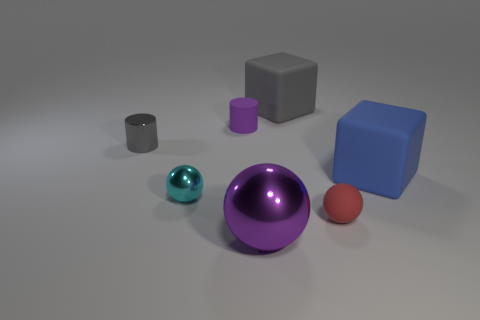There is a small thing that is the same color as the big sphere; what is it made of?
Provide a short and direct response. Rubber. Do the small red object and the small cyan ball have the same material?
Offer a very short reply. No. How many things are either green matte cubes or cylinders?
Provide a succinct answer. 2. What is the shape of the big thing behind the blue rubber cube?
Provide a short and direct response. Cube. The cylinder that is made of the same material as the cyan ball is what color?
Offer a very short reply. Gray. What material is the tiny cyan object that is the same shape as the purple shiny thing?
Make the answer very short. Metal. There is a gray shiny thing; what shape is it?
Give a very brief answer. Cylinder. What material is the ball that is both to the left of the small red matte ball and to the right of the purple matte object?
Offer a terse response. Metal. There is a gray object that is the same material as the big sphere; what is its shape?
Offer a terse response. Cylinder. The blue object that is made of the same material as the tiny purple cylinder is what size?
Ensure brevity in your answer.  Large. 